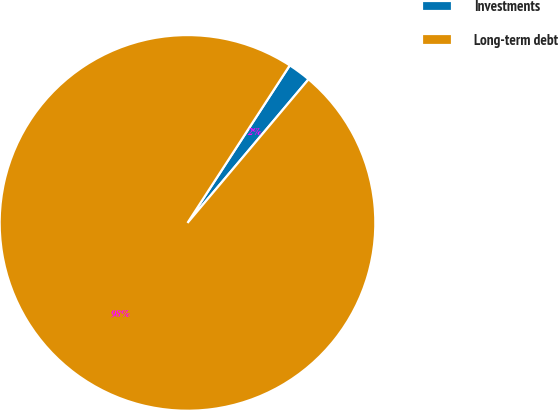Convert chart to OTSL. <chart><loc_0><loc_0><loc_500><loc_500><pie_chart><fcel>Investments<fcel>Long-term debt<nl><fcel>1.98%<fcel>98.02%<nl></chart> 